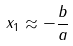Convert formula to latex. <formula><loc_0><loc_0><loc_500><loc_500>x _ { 1 } \approx - \frac { b } { a }</formula> 